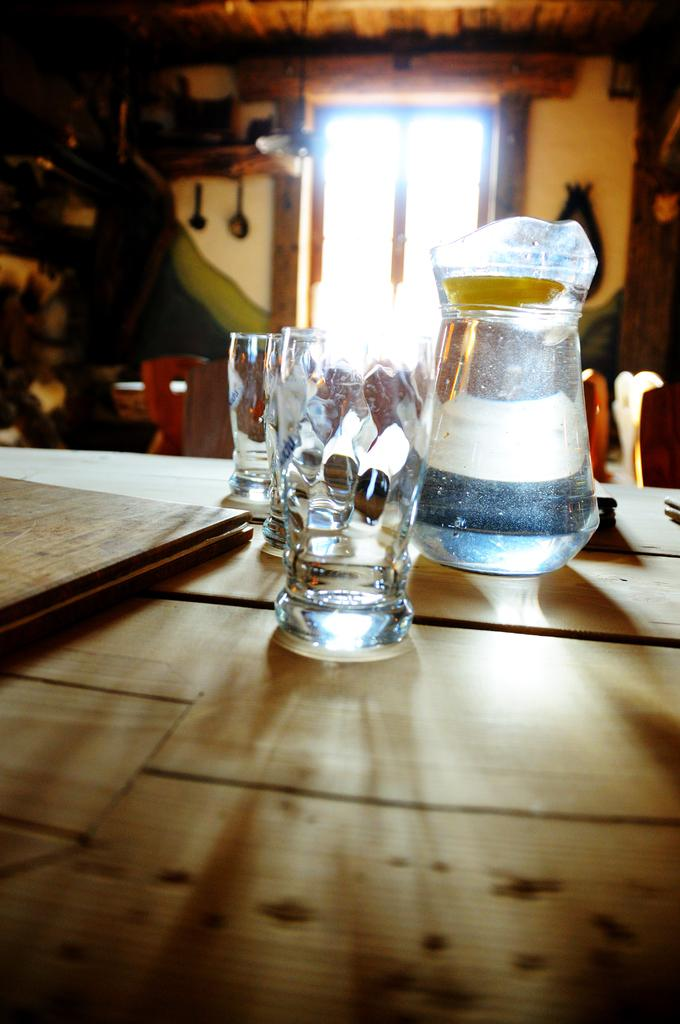What is located in the middle of the image? There is a table in the middle of the image. What objects are on the table? There is a glass, a book, and a jar on the table. What can be seen in the background of the image? There is a window and a wall in the background of the image. What type of cream is being used to scare away the level in the image? There is no cream, scarecrow, or level present in the image. 